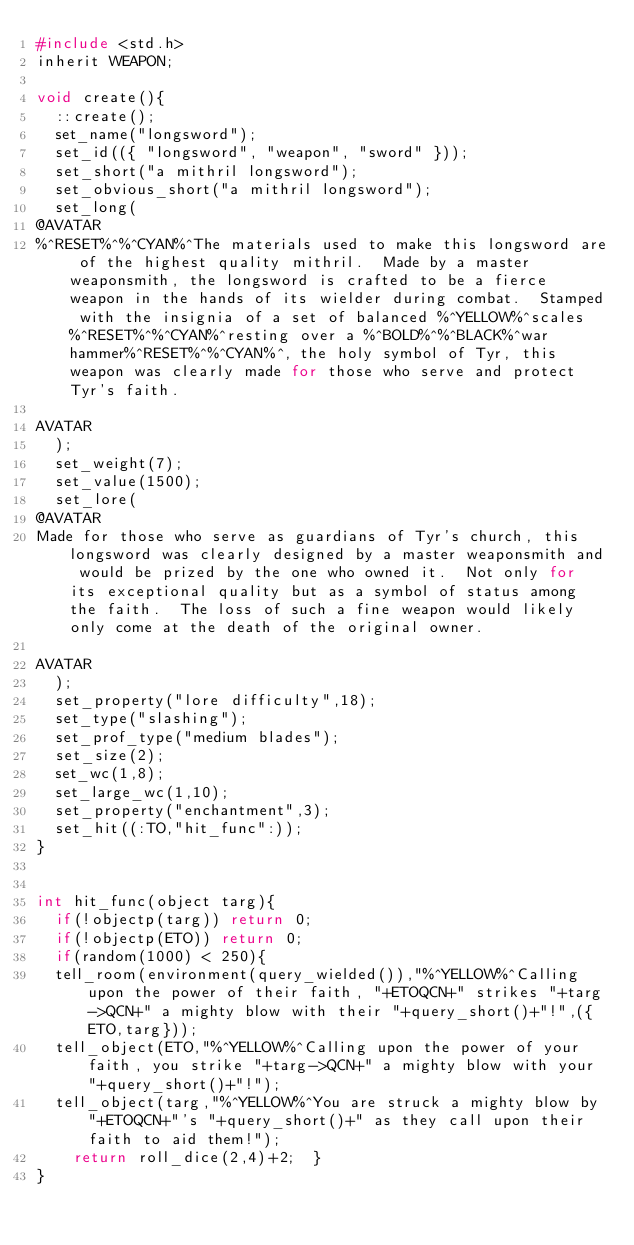<code> <loc_0><loc_0><loc_500><loc_500><_C_>#include <std.h>
inherit WEAPON;

void create(){
	::create();
	set_name("longsword");
	set_id(({ "longsword", "weapon", "sword" }));
	set_short("a mithril longsword");
	set_obvious_short("a mithril longsword");
	set_long(
@AVATAR
%^RESET%^%^CYAN%^The materials used to make this longsword are of the highest quality mithril.  Made by a master weaponsmith, the longsword is crafted to be a fierce weapon in the hands of its wielder during combat.  Stamped with the insignia of a set of balanced %^YELLOW%^scales %^RESET%^%^CYAN%^resting over a %^BOLD%^%^BLACK%^war hammer%^RESET%^%^CYAN%^, the holy symbol of Tyr, this weapon was clearly made for those who serve and protect Tyr's faith.

AVATAR
	);
	set_weight(7);
	set_value(1500);
	set_lore(
@AVATAR
Made for those who serve as guardians of Tyr's church, this longsword was clearly designed by a master weaponsmith and would be prized by the one who owned it.  Not only for its exceptional quality but as a symbol of status among the faith.  The loss of such a fine weapon would likely only come at the death of the original owner.

AVATAR
	);
	set_property("lore difficulty",18);
	set_type("slashing");
	set_prof_type("medium blades");
	set_size(2);
	set_wc(1,8);
	set_large_wc(1,10);
	set_property("enchantment",3);
	set_hit((:TO,"hit_func":));
}


int hit_func(object targ){
	if(!objectp(targ)) return 0;
	if(!objectp(ETO)) return 0;
	if(random(1000) < 250){
	tell_room(environment(query_wielded()),"%^YELLOW%^Calling upon the power of their faith, "+ETOQCN+" strikes "+targ->QCN+" a mighty blow with their "+query_short()+"!",({ETO,targ}));
	tell_object(ETO,"%^YELLOW%^Calling upon the power of your faith, you strike "+targ->QCN+" a mighty blow with your "+query_short()+"!");
	tell_object(targ,"%^YELLOW%^You are struck a mighty blow by "+ETOQCN+"'s "+query_short()+" as they call upon their faith to aid them!");
		return roll_dice(2,4)+2;	}
}</code> 